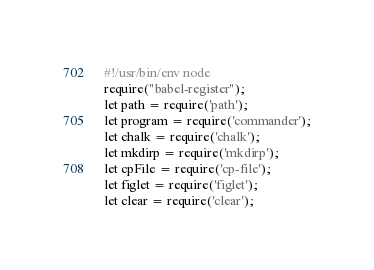Convert code to text. <code><loc_0><loc_0><loc_500><loc_500><_JavaScript_>#!/usr/bin/env node
require("babel-register");
let path = require('path');
let program = require('commander');
let chalk = require('chalk');
let mkdirp = require('mkdirp');
let cpFile = require('cp-file');
let figlet = require('figlet');
let clear = require('clear');</code> 